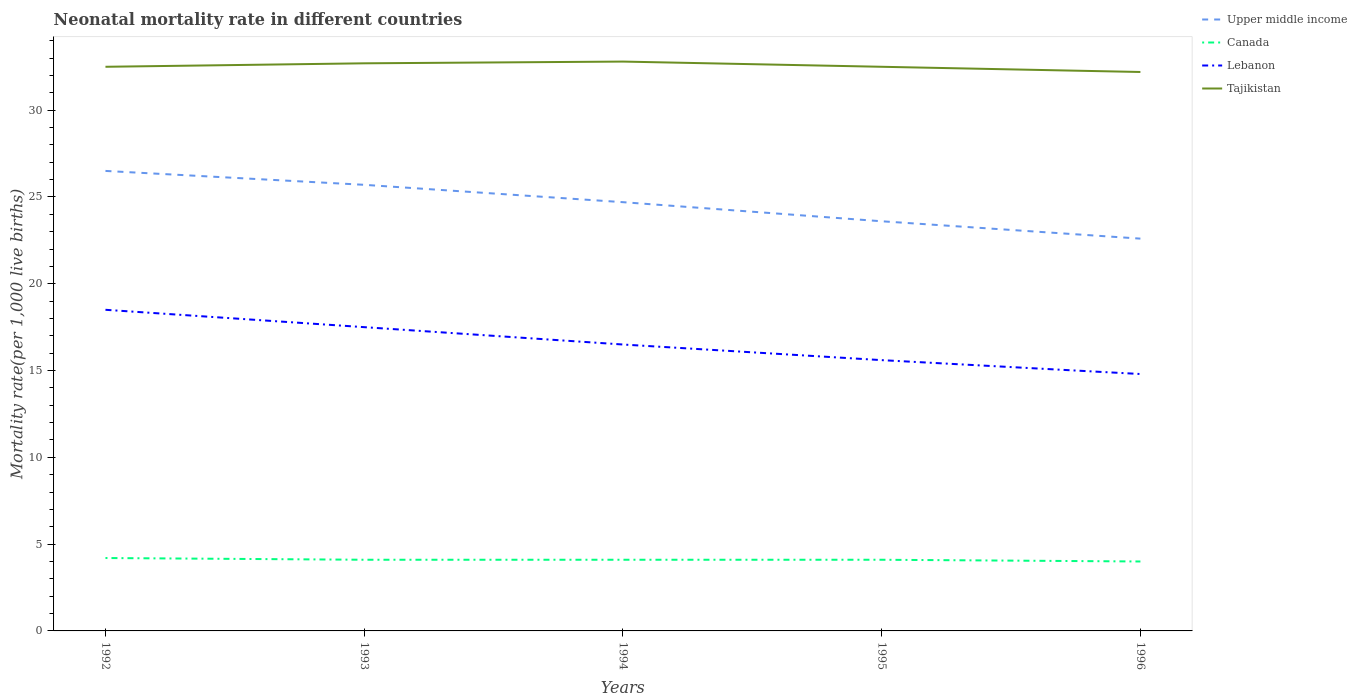Does the line corresponding to Tajikistan intersect with the line corresponding to Canada?
Your response must be concise. No. Is the number of lines equal to the number of legend labels?
Your answer should be compact. Yes. Across all years, what is the maximum neonatal mortality rate in Canada?
Offer a terse response. 4. What is the total neonatal mortality rate in Upper middle income in the graph?
Your answer should be compact. 1.1. What is the difference between the highest and the second highest neonatal mortality rate in Upper middle income?
Your answer should be very brief. 3.9. What is the difference between the highest and the lowest neonatal mortality rate in Lebanon?
Your answer should be very brief. 2. How many lines are there?
Provide a short and direct response. 4. Are the values on the major ticks of Y-axis written in scientific E-notation?
Ensure brevity in your answer.  No. Where does the legend appear in the graph?
Your answer should be very brief. Top right. How many legend labels are there?
Ensure brevity in your answer.  4. How are the legend labels stacked?
Your answer should be compact. Vertical. What is the title of the graph?
Your answer should be very brief. Neonatal mortality rate in different countries. Does "Central African Republic" appear as one of the legend labels in the graph?
Provide a short and direct response. No. What is the label or title of the X-axis?
Your response must be concise. Years. What is the label or title of the Y-axis?
Ensure brevity in your answer.  Mortality rate(per 1,0 live births). What is the Mortality rate(per 1,000 live births) in Lebanon in 1992?
Keep it short and to the point. 18.5. What is the Mortality rate(per 1,000 live births) of Tajikistan in 1992?
Offer a terse response. 32.5. What is the Mortality rate(per 1,000 live births) in Upper middle income in 1993?
Provide a succinct answer. 25.7. What is the Mortality rate(per 1,000 live births) in Canada in 1993?
Offer a very short reply. 4.1. What is the Mortality rate(per 1,000 live births) in Lebanon in 1993?
Ensure brevity in your answer.  17.5. What is the Mortality rate(per 1,000 live births) in Tajikistan in 1993?
Your answer should be very brief. 32.7. What is the Mortality rate(per 1,000 live births) of Upper middle income in 1994?
Your answer should be very brief. 24.7. What is the Mortality rate(per 1,000 live births) in Canada in 1994?
Ensure brevity in your answer.  4.1. What is the Mortality rate(per 1,000 live births) in Lebanon in 1994?
Keep it short and to the point. 16.5. What is the Mortality rate(per 1,000 live births) of Tajikistan in 1994?
Your answer should be compact. 32.8. What is the Mortality rate(per 1,000 live births) in Upper middle income in 1995?
Provide a short and direct response. 23.6. What is the Mortality rate(per 1,000 live births) in Canada in 1995?
Keep it short and to the point. 4.1. What is the Mortality rate(per 1,000 live births) in Lebanon in 1995?
Your answer should be very brief. 15.6. What is the Mortality rate(per 1,000 live births) in Tajikistan in 1995?
Keep it short and to the point. 32.5. What is the Mortality rate(per 1,000 live births) of Upper middle income in 1996?
Provide a short and direct response. 22.6. What is the Mortality rate(per 1,000 live births) in Canada in 1996?
Provide a short and direct response. 4. What is the Mortality rate(per 1,000 live births) in Lebanon in 1996?
Your answer should be compact. 14.8. What is the Mortality rate(per 1,000 live births) in Tajikistan in 1996?
Ensure brevity in your answer.  32.2. Across all years, what is the maximum Mortality rate(per 1,000 live births) of Upper middle income?
Your response must be concise. 26.5. Across all years, what is the maximum Mortality rate(per 1,000 live births) of Lebanon?
Provide a succinct answer. 18.5. Across all years, what is the maximum Mortality rate(per 1,000 live births) of Tajikistan?
Offer a terse response. 32.8. Across all years, what is the minimum Mortality rate(per 1,000 live births) in Upper middle income?
Your answer should be very brief. 22.6. Across all years, what is the minimum Mortality rate(per 1,000 live births) in Canada?
Keep it short and to the point. 4. Across all years, what is the minimum Mortality rate(per 1,000 live births) of Tajikistan?
Ensure brevity in your answer.  32.2. What is the total Mortality rate(per 1,000 live births) of Upper middle income in the graph?
Offer a terse response. 123.1. What is the total Mortality rate(per 1,000 live births) of Lebanon in the graph?
Offer a terse response. 82.9. What is the total Mortality rate(per 1,000 live births) in Tajikistan in the graph?
Make the answer very short. 162.7. What is the difference between the Mortality rate(per 1,000 live births) in Upper middle income in 1992 and that in 1993?
Give a very brief answer. 0.8. What is the difference between the Mortality rate(per 1,000 live births) in Lebanon in 1992 and that in 1993?
Offer a terse response. 1. What is the difference between the Mortality rate(per 1,000 live births) in Upper middle income in 1992 and that in 1994?
Offer a very short reply. 1.8. What is the difference between the Mortality rate(per 1,000 live births) of Canada in 1992 and that in 1994?
Provide a short and direct response. 0.1. What is the difference between the Mortality rate(per 1,000 live births) of Lebanon in 1992 and that in 1994?
Offer a very short reply. 2. What is the difference between the Mortality rate(per 1,000 live births) in Tajikistan in 1992 and that in 1994?
Provide a short and direct response. -0.3. What is the difference between the Mortality rate(per 1,000 live births) of Canada in 1992 and that in 1995?
Provide a succinct answer. 0.1. What is the difference between the Mortality rate(per 1,000 live births) in Upper middle income in 1992 and that in 1996?
Offer a terse response. 3.9. What is the difference between the Mortality rate(per 1,000 live births) in Lebanon in 1992 and that in 1996?
Your response must be concise. 3.7. What is the difference between the Mortality rate(per 1,000 live births) of Tajikistan in 1992 and that in 1996?
Provide a succinct answer. 0.3. What is the difference between the Mortality rate(per 1,000 live births) in Upper middle income in 1993 and that in 1994?
Offer a very short reply. 1. What is the difference between the Mortality rate(per 1,000 live births) of Tajikistan in 1993 and that in 1994?
Offer a terse response. -0.1. What is the difference between the Mortality rate(per 1,000 live births) in Canada in 1993 and that in 1995?
Give a very brief answer. 0. What is the difference between the Mortality rate(per 1,000 live births) of Canada in 1993 and that in 1996?
Keep it short and to the point. 0.1. What is the difference between the Mortality rate(per 1,000 live births) in Lebanon in 1993 and that in 1996?
Provide a succinct answer. 2.7. What is the difference between the Mortality rate(per 1,000 live births) of Upper middle income in 1994 and that in 1995?
Your answer should be very brief. 1.1. What is the difference between the Mortality rate(per 1,000 live births) of Canada in 1994 and that in 1996?
Offer a very short reply. 0.1. What is the difference between the Mortality rate(per 1,000 live births) in Tajikistan in 1994 and that in 1996?
Provide a short and direct response. 0.6. What is the difference between the Mortality rate(per 1,000 live births) in Upper middle income in 1995 and that in 1996?
Provide a succinct answer. 1. What is the difference between the Mortality rate(per 1,000 live births) in Canada in 1995 and that in 1996?
Provide a succinct answer. 0.1. What is the difference between the Mortality rate(per 1,000 live births) in Lebanon in 1995 and that in 1996?
Your response must be concise. 0.8. What is the difference between the Mortality rate(per 1,000 live births) of Upper middle income in 1992 and the Mortality rate(per 1,000 live births) of Canada in 1993?
Offer a very short reply. 22.4. What is the difference between the Mortality rate(per 1,000 live births) of Canada in 1992 and the Mortality rate(per 1,000 live births) of Lebanon in 1993?
Give a very brief answer. -13.3. What is the difference between the Mortality rate(per 1,000 live births) in Canada in 1992 and the Mortality rate(per 1,000 live births) in Tajikistan in 1993?
Offer a very short reply. -28.5. What is the difference between the Mortality rate(per 1,000 live births) of Upper middle income in 1992 and the Mortality rate(per 1,000 live births) of Canada in 1994?
Provide a succinct answer. 22.4. What is the difference between the Mortality rate(per 1,000 live births) of Upper middle income in 1992 and the Mortality rate(per 1,000 live births) of Tajikistan in 1994?
Your answer should be compact. -6.3. What is the difference between the Mortality rate(per 1,000 live births) in Canada in 1992 and the Mortality rate(per 1,000 live births) in Tajikistan in 1994?
Your answer should be very brief. -28.6. What is the difference between the Mortality rate(per 1,000 live births) of Lebanon in 1992 and the Mortality rate(per 1,000 live births) of Tajikistan in 1994?
Offer a terse response. -14.3. What is the difference between the Mortality rate(per 1,000 live births) of Upper middle income in 1992 and the Mortality rate(per 1,000 live births) of Canada in 1995?
Your response must be concise. 22.4. What is the difference between the Mortality rate(per 1,000 live births) of Upper middle income in 1992 and the Mortality rate(per 1,000 live births) of Tajikistan in 1995?
Offer a very short reply. -6. What is the difference between the Mortality rate(per 1,000 live births) in Canada in 1992 and the Mortality rate(per 1,000 live births) in Tajikistan in 1995?
Ensure brevity in your answer.  -28.3. What is the difference between the Mortality rate(per 1,000 live births) in Lebanon in 1992 and the Mortality rate(per 1,000 live births) in Tajikistan in 1995?
Make the answer very short. -14. What is the difference between the Mortality rate(per 1,000 live births) of Upper middle income in 1992 and the Mortality rate(per 1,000 live births) of Canada in 1996?
Make the answer very short. 22.5. What is the difference between the Mortality rate(per 1,000 live births) in Upper middle income in 1992 and the Mortality rate(per 1,000 live births) in Lebanon in 1996?
Provide a short and direct response. 11.7. What is the difference between the Mortality rate(per 1,000 live births) in Upper middle income in 1992 and the Mortality rate(per 1,000 live births) in Tajikistan in 1996?
Your response must be concise. -5.7. What is the difference between the Mortality rate(per 1,000 live births) of Canada in 1992 and the Mortality rate(per 1,000 live births) of Lebanon in 1996?
Keep it short and to the point. -10.6. What is the difference between the Mortality rate(per 1,000 live births) in Lebanon in 1992 and the Mortality rate(per 1,000 live births) in Tajikistan in 1996?
Give a very brief answer. -13.7. What is the difference between the Mortality rate(per 1,000 live births) of Upper middle income in 1993 and the Mortality rate(per 1,000 live births) of Canada in 1994?
Give a very brief answer. 21.6. What is the difference between the Mortality rate(per 1,000 live births) in Upper middle income in 1993 and the Mortality rate(per 1,000 live births) in Lebanon in 1994?
Ensure brevity in your answer.  9.2. What is the difference between the Mortality rate(per 1,000 live births) in Upper middle income in 1993 and the Mortality rate(per 1,000 live births) in Tajikistan in 1994?
Your answer should be compact. -7.1. What is the difference between the Mortality rate(per 1,000 live births) of Canada in 1993 and the Mortality rate(per 1,000 live births) of Tajikistan in 1994?
Your answer should be very brief. -28.7. What is the difference between the Mortality rate(per 1,000 live births) of Lebanon in 1993 and the Mortality rate(per 1,000 live births) of Tajikistan in 1994?
Your answer should be compact. -15.3. What is the difference between the Mortality rate(per 1,000 live births) in Upper middle income in 1993 and the Mortality rate(per 1,000 live births) in Canada in 1995?
Your answer should be compact. 21.6. What is the difference between the Mortality rate(per 1,000 live births) in Canada in 1993 and the Mortality rate(per 1,000 live births) in Lebanon in 1995?
Your answer should be very brief. -11.5. What is the difference between the Mortality rate(per 1,000 live births) in Canada in 1993 and the Mortality rate(per 1,000 live births) in Tajikistan in 1995?
Ensure brevity in your answer.  -28.4. What is the difference between the Mortality rate(per 1,000 live births) of Upper middle income in 1993 and the Mortality rate(per 1,000 live births) of Canada in 1996?
Keep it short and to the point. 21.7. What is the difference between the Mortality rate(per 1,000 live births) in Upper middle income in 1993 and the Mortality rate(per 1,000 live births) in Lebanon in 1996?
Provide a short and direct response. 10.9. What is the difference between the Mortality rate(per 1,000 live births) of Upper middle income in 1993 and the Mortality rate(per 1,000 live births) of Tajikistan in 1996?
Ensure brevity in your answer.  -6.5. What is the difference between the Mortality rate(per 1,000 live births) of Canada in 1993 and the Mortality rate(per 1,000 live births) of Lebanon in 1996?
Your response must be concise. -10.7. What is the difference between the Mortality rate(per 1,000 live births) of Canada in 1993 and the Mortality rate(per 1,000 live births) of Tajikistan in 1996?
Ensure brevity in your answer.  -28.1. What is the difference between the Mortality rate(per 1,000 live births) of Lebanon in 1993 and the Mortality rate(per 1,000 live births) of Tajikistan in 1996?
Make the answer very short. -14.7. What is the difference between the Mortality rate(per 1,000 live births) of Upper middle income in 1994 and the Mortality rate(per 1,000 live births) of Canada in 1995?
Your answer should be very brief. 20.6. What is the difference between the Mortality rate(per 1,000 live births) of Canada in 1994 and the Mortality rate(per 1,000 live births) of Lebanon in 1995?
Your answer should be very brief. -11.5. What is the difference between the Mortality rate(per 1,000 live births) in Canada in 1994 and the Mortality rate(per 1,000 live births) in Tajikistan in 1995?
Offer a terse response. -28.4. What is the difference between the Mortality rate(per 1,000 live births) of Upper middle income in 1994 and the Mortality rate(per 1,000 live births) of Canada in 1996?
Provide a succinct answer. 20.7. What is the difference between the Mortality rate(per 1,000 live births) in Upper middle income in 1994 and the Mortality rate(per 1,000 live births) in Lebanon in 1996?
Make the answer very short. 9.9. What is the difference between the Mortality rate(per 1,000 live births) of Canada in 1994 and the Mortality rate(per 1,000 live births) of Lebanon in 1996?
Your answer should be compact. -10.7. What is the difference between the Mortality rate(per 1,000 live births) of Canada in 1994 and the Mortality rate(per 1,000 live births) of Tajikistan in 1996?
Provide a short and direct response. -28.1. What is the difference between the Mortality rate(per 1,000 live births) in Lebanon in 1994 and the Mortality rate(per 1,000 live births) in Tajikistan in 1996?
Make the answer very short. -15.7. What is the difference between the Mortality rate(per 1,000 live births) of Upper middle income in 1995 and the Mortality rate(per 1,000 live births) of Canada in 1996?
Ensure brevity in your answer.  19.6. What is the difference between the Mortality rate(per 1,000 live births) of Canada in 1995 and the Mortality rate(per 1,000 live births) of Tajikistan in 1996?
Your answer should be very brief. -28.1. What is the difference between the Mortality rate(per 1,000 live births) in Lebanon in 1995 and the Mortality rate(per 1,000 live births) in Tajikistan in 1996?
Your response must be concise. -16.6. What is the average Mortality rate(per 1,000 live births) of Upper middle income per year?
Give a very brief answer. 24.62. What is the average Mortality rate(per 1,000 live births) in Canada per year?
Your answer should be very brief. 4.1. What is the average Mortality rate(per 1,000 live births) of Lebanon per year?
Your response must be concise. 16.58. What is the average Mortality rate(per 1,000 live births) in Tajikistan per year?
Make the answer very short. 32.54. In the year 1992, what is the difference between the Mortality rate(per 1,000 live births) in Upper middle income and Mortality rate(per 1,000 live births) in Canada?
Your answer should be very brief. 22.3. In the year 1992, what is the difference between the Mortality rate(per 1,000 live births) in Canada and Mortality rate(per 1,000 live births) in Lebanon?
Your response must be concise. -14.3. In the year 1992, what is the difference between the Mortality rate(per 1,000 live births) of Canada and Mortality rate(per 1,000 live births) of Tajikistan?
Provide a short and direct response. -28.3. In the year 1992, what is the difference between the Mortality rate(per 1,000 live births) of Lebanon and Mortality rate(per 1,000 live births) of Tajikistan?
Ensure brevity in your answer.  -14. In the year 1993, what is the difference between the Mortality rate(per 1,000 live births) of Upper middle income and Mortality rate(per 1,000 live births) of Canada?
Your answer should be compact. 21.6. In the year 1993, what is the difference between the Mortality rate(per 1,000 live births) of Upper middle income and Mortality rate(per 1,000 live births) of Lebanon?
Provide a short and direct response. 8.2. In the year 1993, what is the difference between the Mortality rate(per 1,000 live births) in Canada and Mortality rate(per 1,000 live births) in Tajikistan?
Keep it short and to the point. -28.6. In the year 1993, what is the difference between the Mortality rate(per 1,000 live births) in Lebanon and Mortality rate(per 1,000 live births) in Tajikistan?
Your answer should be compact. -15.2. In the year 1994, what is the difference between the Mortality rate(per 1,000 live births) in Upper middle income and Mortality rate(per 1,000 live births) in Canada?
Give a very brief answer. 20.6. In the year 1994, what is the difference between the Mortality rate(per 1,000 live births) in Upper middle income and Mortality rate(per 1,000 live births) in Tajikistan?
Offer a terse response. -8.1. In the year 1994, what is the difference between the Mortality rate(per 1,000 live births) in Canada and Mortality rate(per 1,000 live births) in Lebanon?
Your answer should be very brief. -12.4. In the year 1994, what is the difference between the Mortality rate(per 1,000 live births) in Canada and Mortality rate(per 1,000 live births) in Tajikistan?
Offer a terse response. -28.7. In the year 1994, what is the difference between the Mortality rate(per 1,000 live births) of Lebanon and Mortality rate(per 1,000 live births) of Tajikistan?
Make the answer very short. -16.3. In the year 1995, what is the difference between the Mortality rate(per 1,000 live births) in Upper middle income and Mortality rate(per 1,000 live births) in Canada?
Your answer should be compact. 19.5. In the year 1995, what is the difference between the Mortality rate(per 1,000 live births) of Canada and Mortality rate(per 1,000 live births) of Lebanon?
Provide a short and direct response. -11.5. In the year 1995, what is the difference between the Mortality rate(per 1,000 live births) in Canada and Mortality rate(per 1,000 live births) in Tajikistan?
Provide a short and direct response. -28.4. In the year 1995, what is the difference between the Mortality rate(per 1,000 live births) of Lebanon and Mortality rate(per 1,000 live births) of Tajikistan?
Provide a short and direct response. -16.9. In the year 1996, what is the difference between the Mortality rate(per 1,000 live births) in Canada and Mortality rate(per 1,000 live births) in Tajikistan?
Make the answer very short. -28.2. In the year 1996, what is the difference between the Mortality rate(per 1,000 live births) of Lebanon and Mortality rate(per 1,000 live births) of Tajikistan?
Provide a succinct answer. -17.4. What is the ratio of the Mortality rate(per 1,000 live births) of Upper middle income in 1992 to that in 1993?
Make the answer very short. 1.03. What is the ratio of the Mortality rate(per 1,000 live births) in Canada in 1992 to that in 1993?
Offer a very short reply. 1.02. What is the ratio of the Mortality rate(per 1,000 live births) of Lebanon in 1992 to that in 1993?
Give a very brief answer. 1.06. What is the ratio of the Mortality rate(per 1,000 live births) of Tajikistan in 1992 to that in 1993?
Offer a terse response. 0.99. What is the ratio of the Mortality rate(per 1,000 live births) in Upper middle income in 1992 to that in 1994?
Offer a terse response. 1.07. What is the ratio of the Mortality rate(per 1,000 live births) in Canada in 1992 to that in 1994?
Keep it short and to the point. 1.02. What is the ratio of the Mortality rate(per 1,000 live births) in Lebanon in 1992 to that in 1994?
Your answer should be very brief. 1.12. What is the ratio of the Mortality rate(per 1,000 live births) of Tajikistan in 1992 to that in 1994?
Ensure brevity in your answer.  0.99. What is the ratio of the Mortality rate(per 1,000 live births) in Upper middle income in 1992 to that in 1995?
Keep it short and to the point. 1.12. What is the ratio of the Mortality rate(per 1,000 live births) of Canada in 1992 to that in 1995?
Ensure brevity in your answer.  1.02. What is the ratio of the Mortality rate(per 1,000 live births) of Lebanon in 1992 to that in 1995?
Keep it short and to the point. 1.19. What is the ratio of the Mortality rate(per 1,000 live births) in Tajikistan in 1992 to that in 1995?
Provide a succinct answer. 1. What is the ratio of the Mortality rate(per 1,000 live births) in Upper middle income in 1992 to that in 1996?
Offer a terse response. 1.17. What is the ratio of the Mortality rate(per 1,000 live births) in Tajikistan in 1992 to that in 1996?
Your answer should be very brief. 1.01. What is the ratio of the Mortality rate(per 1,000 live births) of Upper middle income in 1993 to that in 1994?
Keep it short and to the point. 1.04. What is the ratio of the Mortality rate(per 1,000 live births) in Canada in 1993 to that in 1994?
Your response must be concise. 1. What is the ratio of the Mortality rate(per 1,000 live births) in Lebanon in 1993 to that in 1994?
Offer a terse response. 1.06. What is the ratio of the Mortality rate(per 1,000 live births) in Tajikistan in 1993 to that in 1994?
Offer a terse response. 1. What is the ratio of the Mortality rate(per 1,000 live births) of Upper middle income in 1993 to that in 1995?
Provide a succinct answer. 1.09. What is the ratio of the Mortality rate(per 1,000 live births) in Lebanon in 1993 to that in 1995?
Your answer should be compact. 1.12. What is the ratio of the Mortality rate(per 1,000 live births) in Upper middle income in 1993 to that in 1996?
Give a very brief answer. 1.14. What is the ratio of the Mortality rate(per 1,000 live births) of Canada in 1993 to that in 1996?
Provide a succinct answer. 1.02. What is the ratio of the Mortality rate(per 1,000 live births) of Lebanon in 1993 to that in 1996?
Ensure brevity in your answer.  1.18. What is the ratio of the Mortality rate(per 1,000 live births) of Tajikistan in 1993 to that in 1996?
Keep it short and to the point. 1.02. What is the ratio of the Mortality rate(per 1,000 live births) of Upper middle income in 1994 to that in 1995?
Offer a terse response. 1.05. What is the ratio of the Mortality rate(per 1,000 live births) in Lebanon in 1994 to that in 1995?
Give a very brief answer. 1.06. What is the ratio of the Mortality rate(per 1,000 live births) in Tajikistan in 1994 to that in 1995?
Your answer should be compact. 1.01. What is the ratio of the Mortality rate(per 1,000 live births) in Upper middle income in 1994 to that in 1996?
Make the answer very short. 1.09. What is the ratio of the Mortality rate(per 1,000 live births) of Canada in 1994 to that in 1996?
Your response must be concise. 1.02. What is the ratio of the Mortality rate(per 1,000 live births) of Lebanon in 1994 to that in 1996?
Ensure brevity in your answer.  1.11. What is the ratio of the Mortality rate(per 1,000 live births) of Tajikistan in 1994 to that in 1996?
Give a very brief answer. 1.02. What is the ratio of the Mortality rate(per 1,000 live births) in Upper middle income in 1995 to that in 1996?
Give a very brief answer. 1.04. What is the ratio of the Mortality rate(per 1,000 live births) of Canada in 1995 to that in 1996?
Give a very brief answer. 1.02. What is the ratio of the Mortality rate(per 1,000 live births) of Lebanon in 1995 to that in 1996?
Keep it short and to the point. 1.05. What is the ratio of the Mortality rate(per 1,000 live births) of Tajikistan in 1995 to that in 1996?
Ensure brevity in your answer.  1.01. What is the difference between the highest and the second highest Mortality rate(per 1,000 live births) in Canada?
Your response must be concise. 0.1. What is the difference between the highest and the lowest Mortality rate(per 1,000 live births) of Upper middle income?
Offer a terse response. 3.9. What is the difference between the highest and the lowest Mortality rate(per 1,000 live births) of Lebanon?
Keep it short and to the point. 3.7. What is the difference between the highest and the lowest Mortality rate(per 1,000 live births) in Tajikistan?
Give a very brief answer. 0.6. 